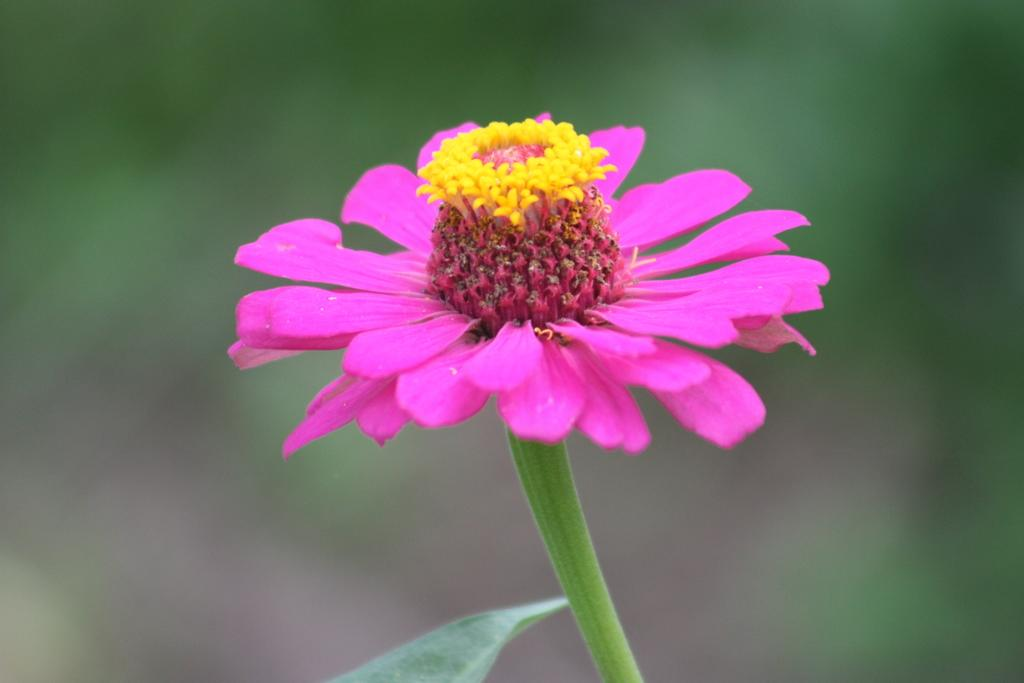What is the main subject of the image? There is a flower in the image. Can you describe the colors of the flower? The flower has pink and yellow colors. What color is the background of the image? The background of the image is green. How is the background of the image depicted? The background of the image is blurred. Can you see any ducks taking a bath in the air in the image? There are no ducks or any indication of bathing or air in the image; it features a flower with a green background. 